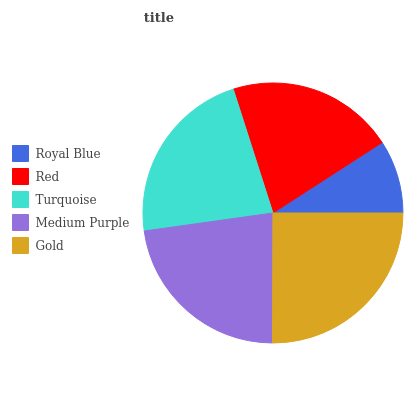Is Royal Blue the minimum?
Answer yes or no. Yes. Is Gold the maximum?
Answer yes or no. Yes. Is Red the minimum?
Answer yes or no. No. Is Red the maximum?
Answer yes or no. No. Is Red greater than Royal Blue?
Answer yes or no. Yes. Is Royal Blue less than Red?
Answer yes or no. Yes. Is Royal Blue greater than Red?
Answer yes or no. No. Is Red less than Royal Blue?
Answer yes or no. No. Is Turquoise the high median?
Answer yes or no. Yes. Is Turquoise the low median?
Answer yes or no. Yes. Is Red the high median?
Answer yes or no. No. Is Royal Blue the low median?
Answer yes or no. No. 